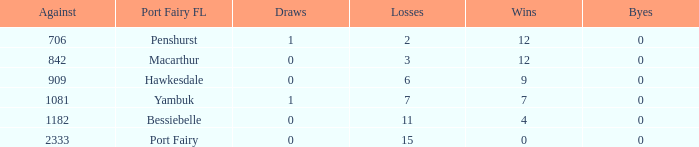How many draws when the Port Fairy FL is Hawkesdale and there are more than 9 wins? None. 